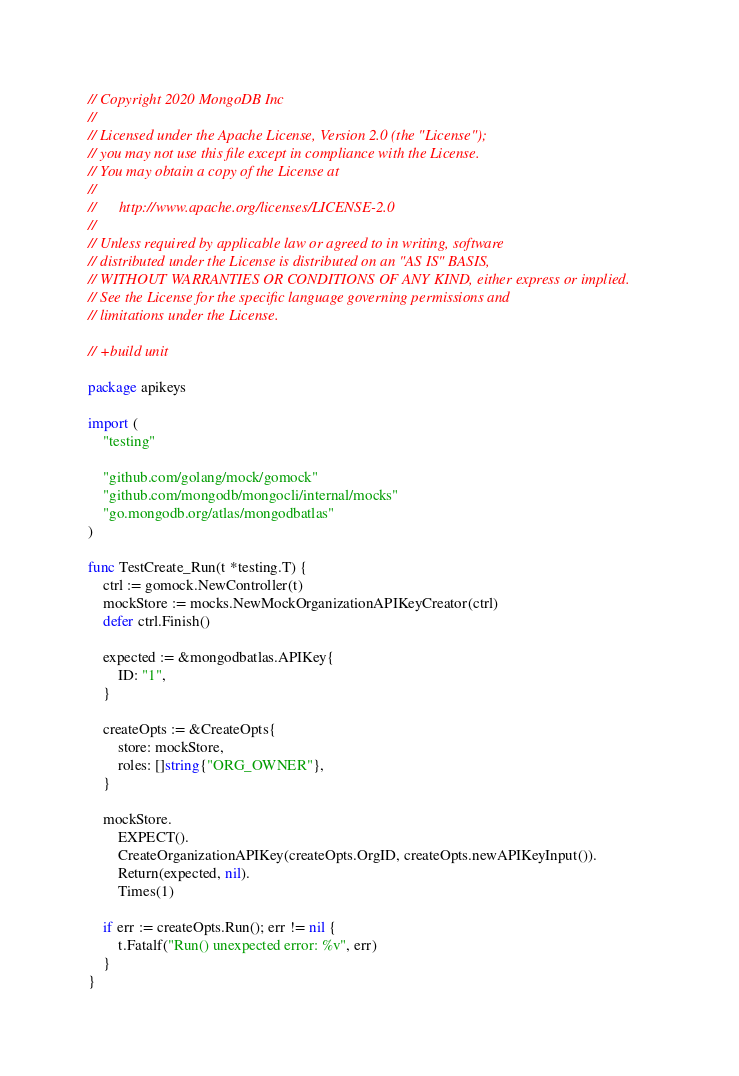<code> <loc_0><loc_0><loc_500><loc_500><_Go_>// Copyright 2020 MongoDB Inc
//
// Licensed under the Apache License, Version 2.0 (the "License");
// you may not use this file except in compliance with the License.
// You may obtain a copy of the License at
//
//      http://www.apache.org/licenses/LICENSE-2.0
//
// Unless required by applicable law or agreed to in writing, software
// distributed under the License is distributed on an "AS IS" BASIS,
// WITHOUT WARRANTIES OR CONDITIONS OF ANY KIND, either express or implied.
// See the License for the specific language governing permissions and
// limitations under the License.

// +build unit

package apikeys

import (
	"testing"

	"github.com/golang/mock/gomock"
	"github.com/mongodb/mongocli/internal/mocks"
	"go.mongodb.org/atlas/mongodbatlas"
)

func TestCreate_Run(t *testing.T) {
	ctrl := gomock.NewController(t)
	mockStore := mocks.NewMockOrganizationAPIKeyCreator(ctrl)
	defer ctrl.Finish()

	expected := &mongodbatlas.APIKey{
		ID: "1",
	}

	createOpts := &CreateOpts{
		store: mockStore,
		roles: []string{"ORG_OWNER"},
	}

	mockStore.
		EXPECT().
		CreateOrganizationAPIKey(createOpts.OrgID, createOpts.newAPIKeyInput()).
		Return(expected, nil).
		Times(1)

	if err := createOpts.Run(); err != nil {
		t.Fatalf("Run() unexpected error: %v", err)
	}
}
</code> 